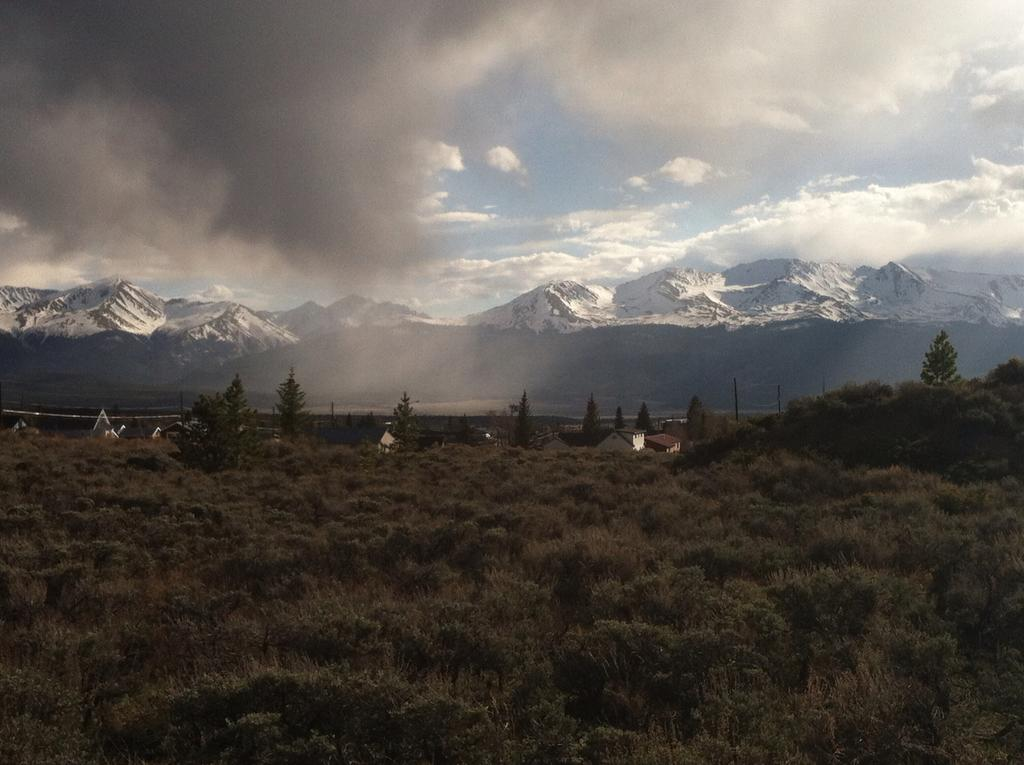What type of vegetation can be seen in the image? There are plants and trees in the image. What can be seen in the background of the image? There are buildings and mountains visible in the background of the image. What is visible in the sky in the image? There are clouds in the sky. What type of ticket is required to enter the mountains in the image? There is no mention of a ticket or any requirement to enter the mountains in the image. 